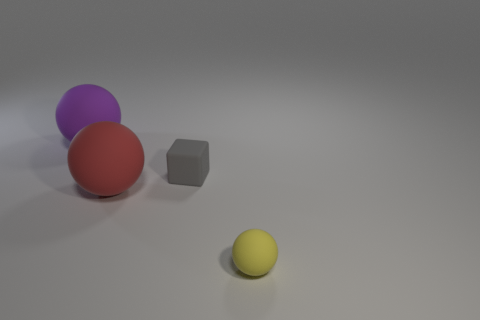What material is the sphere that is the same size as the block? The sphere that appears to be the same size as the grey block in the image has a matte surface that hints at a rubber-like material, which is conducive for grip and elasticity. 